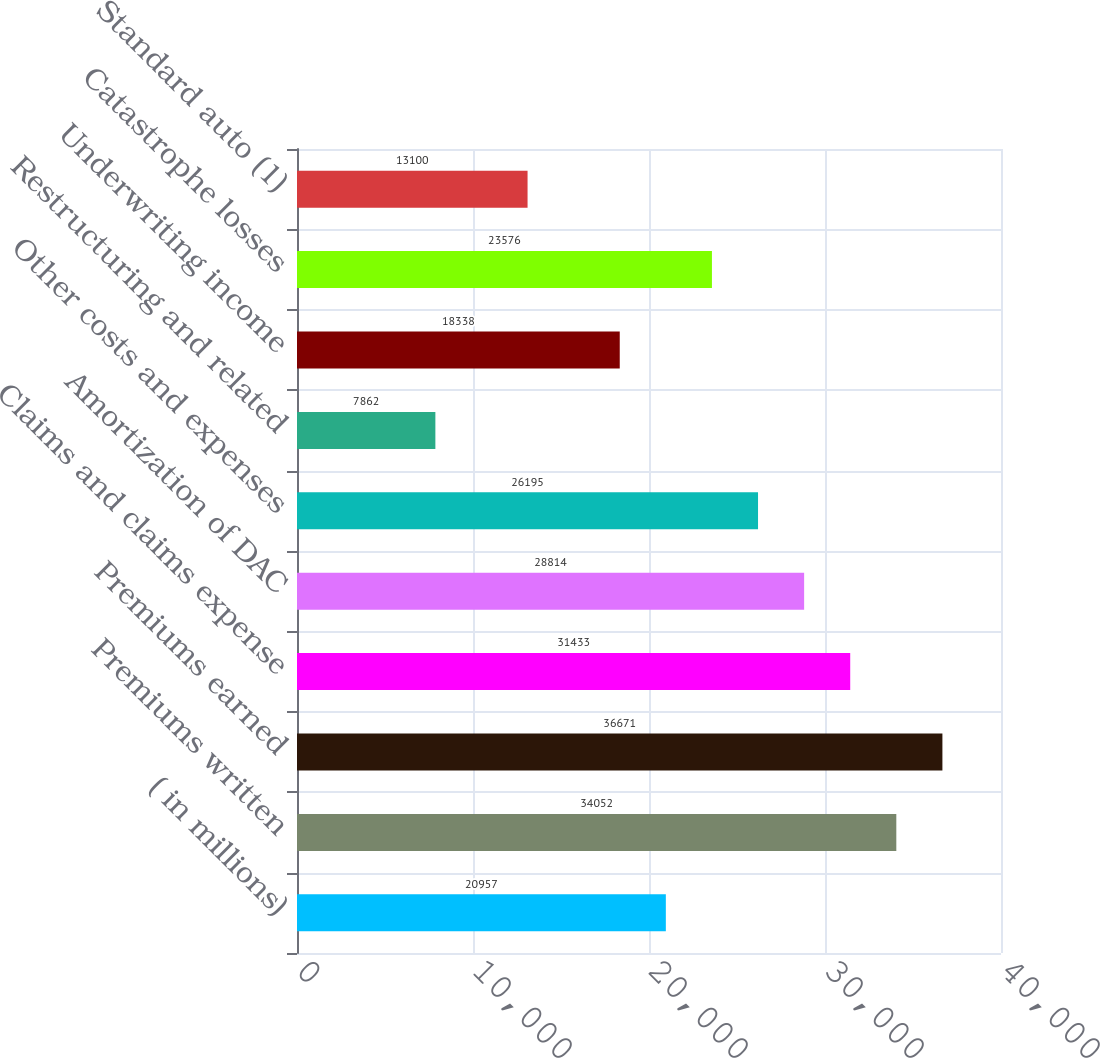Convert chart. <chart><loc_0><loc_0><loc_500><loc_500><bar_chart><fcel>( in millions)<fcel>Premiums written<fcel>Premiums earned<fcel>Claims and claims expense<fcel>Amortization of DAC<fcel>Other costs and expenses<fcel>Restructuring and related<fcel>Underwriting income<fcel>Catastrophe losses<fcel>Standard auto (1)<nl><fcel>20957<fcel>34052<fcel>36671<fcel>31433<fcel>28814<fcel>26195<fcel>7862<fcel>18338<fcel>23576<fcel>13100<nl></chart> 